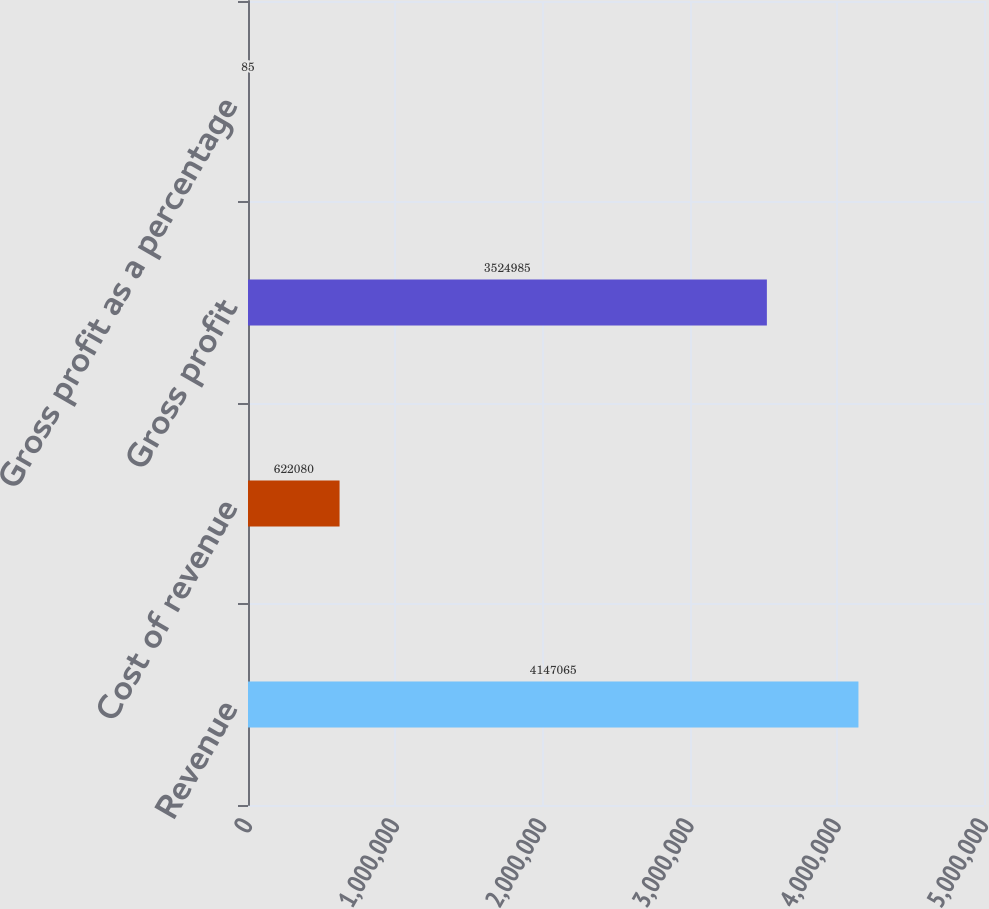Convert chart. <chart><loc_0><loc_0><loc_500><loc_500><bar_chart><fcel>Revenue<fcel>Cost of revenue<fcel>Gross profit<fcel>Gross profit as a percentage<nl><fcel>4.14706e+06<fcel>622080<fcel>3.52498e+06<fcel>85<nl></chart> 